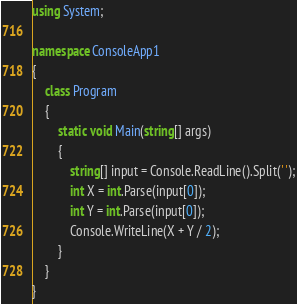<code> <loc_0><loc_0><loc_500><loc_500><_C#_>using System;

namespace ConsoleApp1
{
    class Program
    {
        static void Main(string[] args)
        {
            string[] input = Console.ReadLine().Split(' ');
            int X = int.Parse(input[0]);
            int Y = int.Parse(input[0]);
            Console.WriteLine(X + Y / 2);
        }
    }
}
</code> 